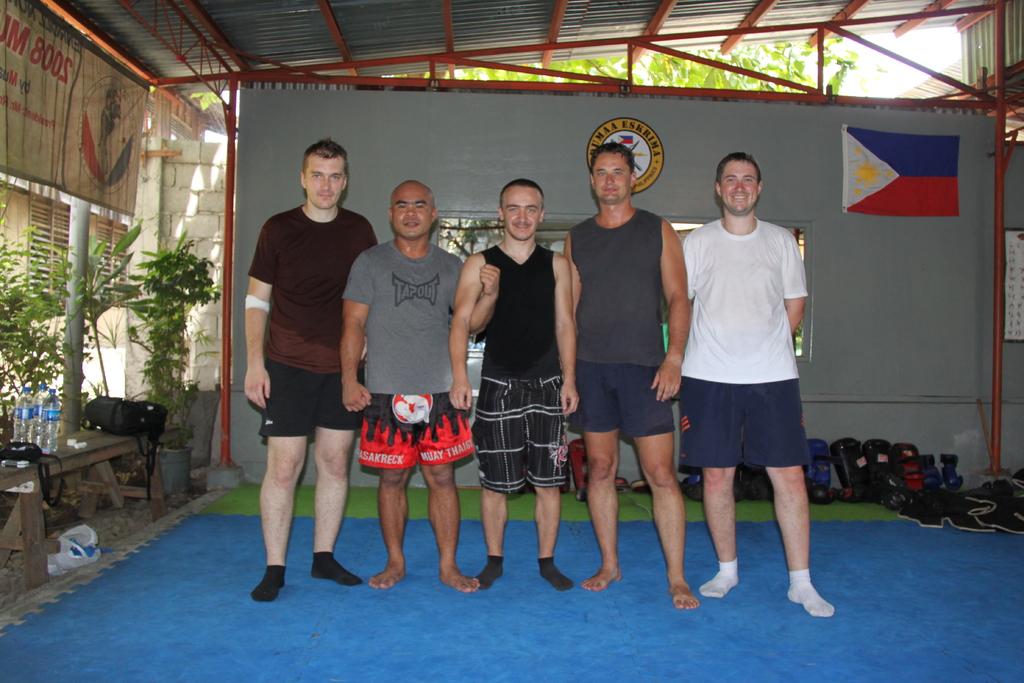Does the man wearing the black and red shorts have muay thai written on them?
Make the answer very short. Yes. 